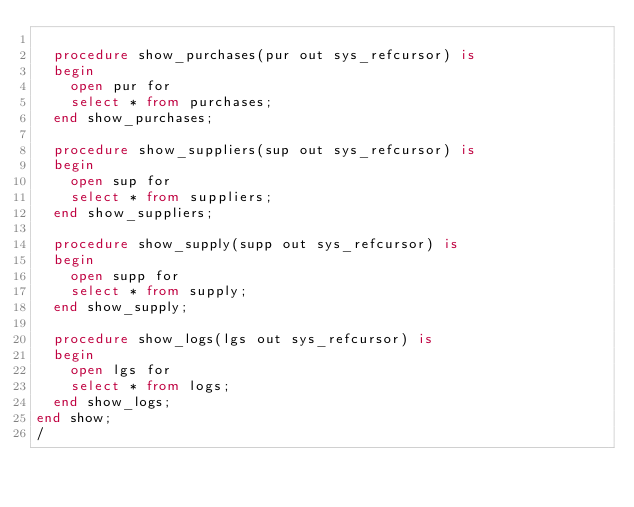<code> <loc_0><loc_0><loc_500><loc_500><_SQL_>	
	procedure show_purchases(pur out sys_refcursor) is 
	begin 
		open pur for
		select * from purchases;
	end show_purchases;
	
	procedure show_suppliers(sup out sys_refcursor) is 
	begin 
		open sup for
		select * from suppliers;
	end show_suppliers;
	
	procedure show_supply(supp out sys_refcursor) is 
	begin 
		open supp for
		select * from supply;
	end show_supply;
	
	procedure show_logs(lgs out sys_refcursor) is 
	begin 
		open lgs for
		select * from logs;
	end show_logs;
end show;
/</code> 